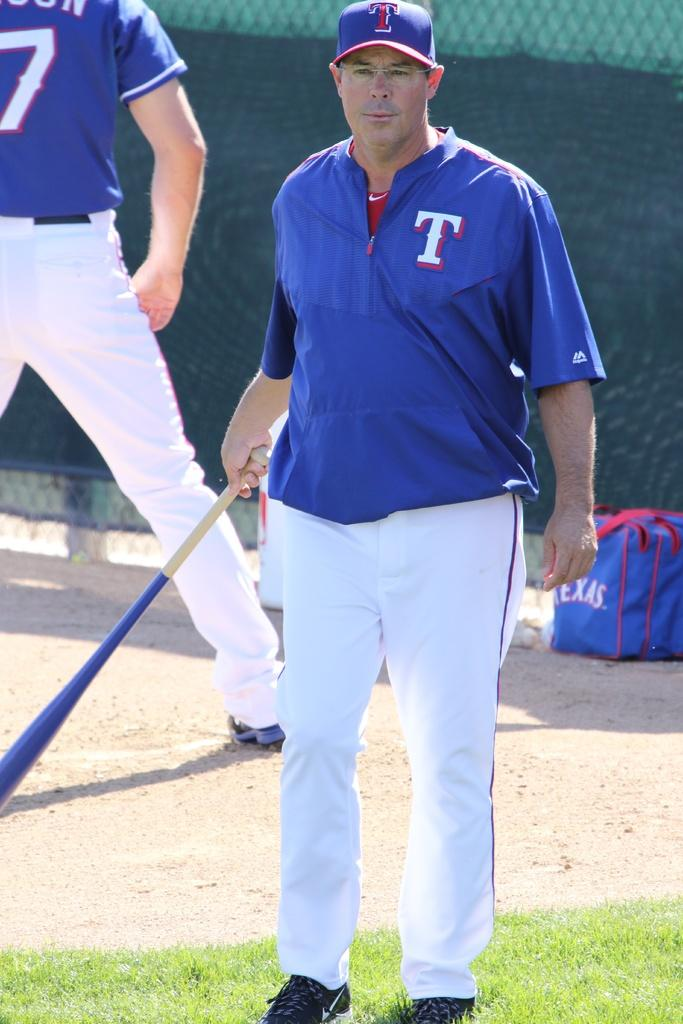<image>
Render a clear and concise summary of the photo. A man is in a blue shirt with a T on it and is holding a bat. 